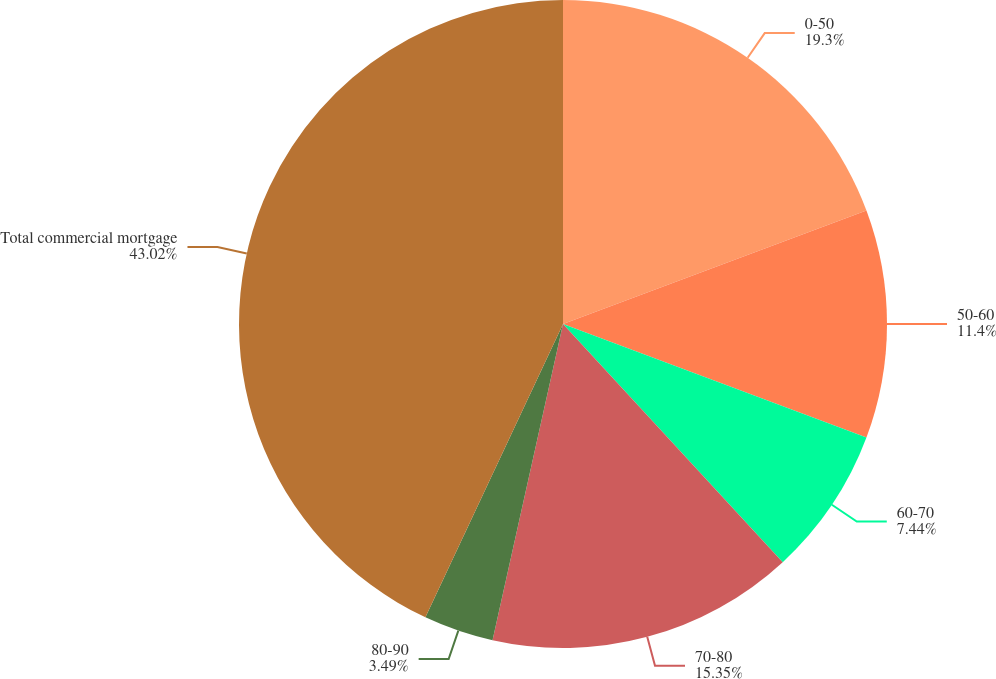Convert chart to OTSL. <chart><loc_0><loc_0><loc_500><loc_500><pie_chart><fcel>0-50<fcel>50-60<fcel>60-70<fcel>70-80<fcel>80-90<fcel>Total commercial mortgage<nl><fcel>19.3%<fcel>11.4%<fcel>7.44%<fcel>15.35%<fcel>3.49%<fcel>43.02%<nl></chart> 